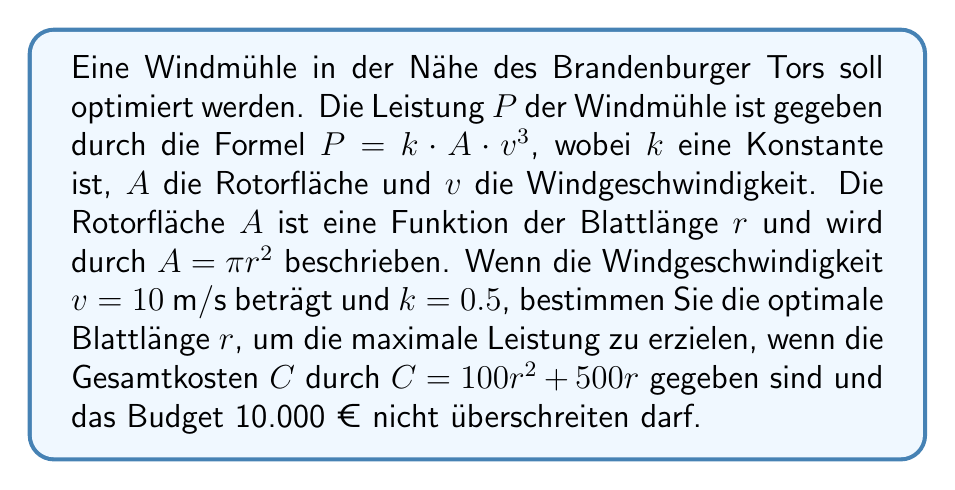What is the answer to this math problem? 1) Zuerst stellen wir die Leistungsfunktion in Bezug auf $r$ auf:
   $P = k \cdot A \cdot v^3$
   $P = 0.5 \cdot \pi r^2 \cdot 10^3$
   $P = 5000\pi r^2$

2) Die Kostenfunktion ist gegeben als:
   $C = 100r^2 + 500r$

3) Wir müssen $C$ maximieren, unter der Bedingung, dass $C \leq 10000$:
   $100r^2 + 500r = 10000$

4) Lösen wir diese quadratische Gleichung:
   $100r^2 + 500r - 10000 = 0$
   $r = \frac{-500 \pm \sqrt{500^2 + 4 \cdot 100 \cdot 10000}}{2 \cdot 100}$
   $r \approx 8.7$ oder $r \approx -11.7$ (die negative Lösung ignorieren wir)

5) Die optimale Blattlänge beträgt also etwa 8.7 Meter.

6) Die maximale Leistung bei dieser Blattlänge ist:
   $P = 5000\pi (8.7)^2 \approx 1,188,229$ Watt oder etwa 1.19 MW
Answer: 8.7 m 